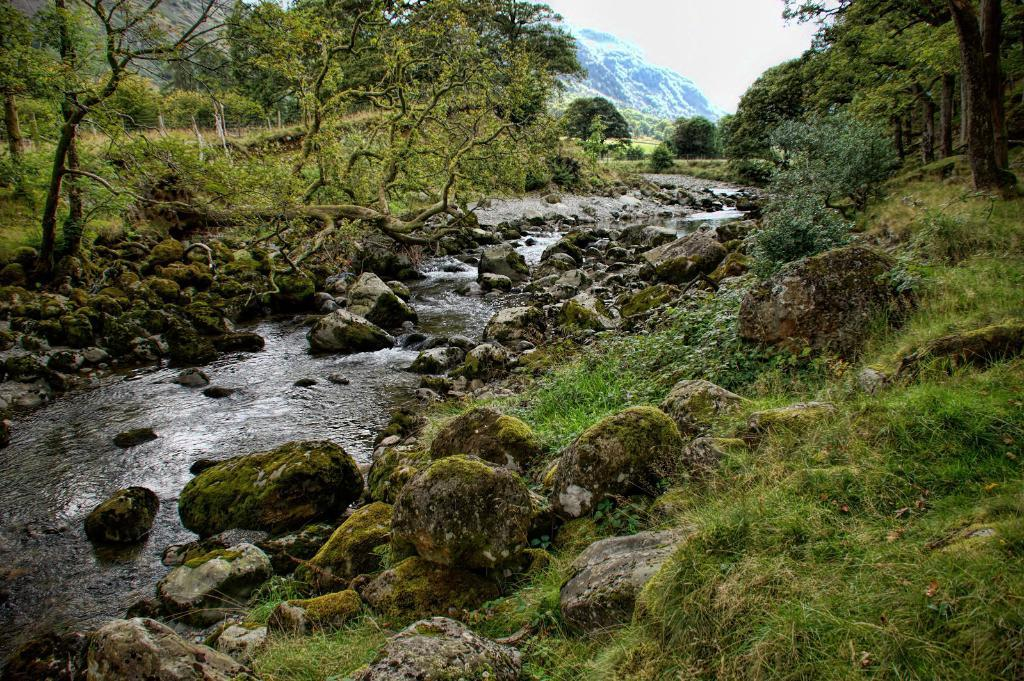What is happening on the ground in the image? There is water flowing on the ground in the image. What type of natural features can be seen in the image? There are rocks and trees in the image. What is covering the ground in the image? The ground is covered with grass. What type of competition is taking place in the image? There is no competition present in the image; it features water flowing on the ground, rocks, trees, and grass-covered ground. Can you see a bee buzzing around the trees in the image? There is no bee present in the image. 